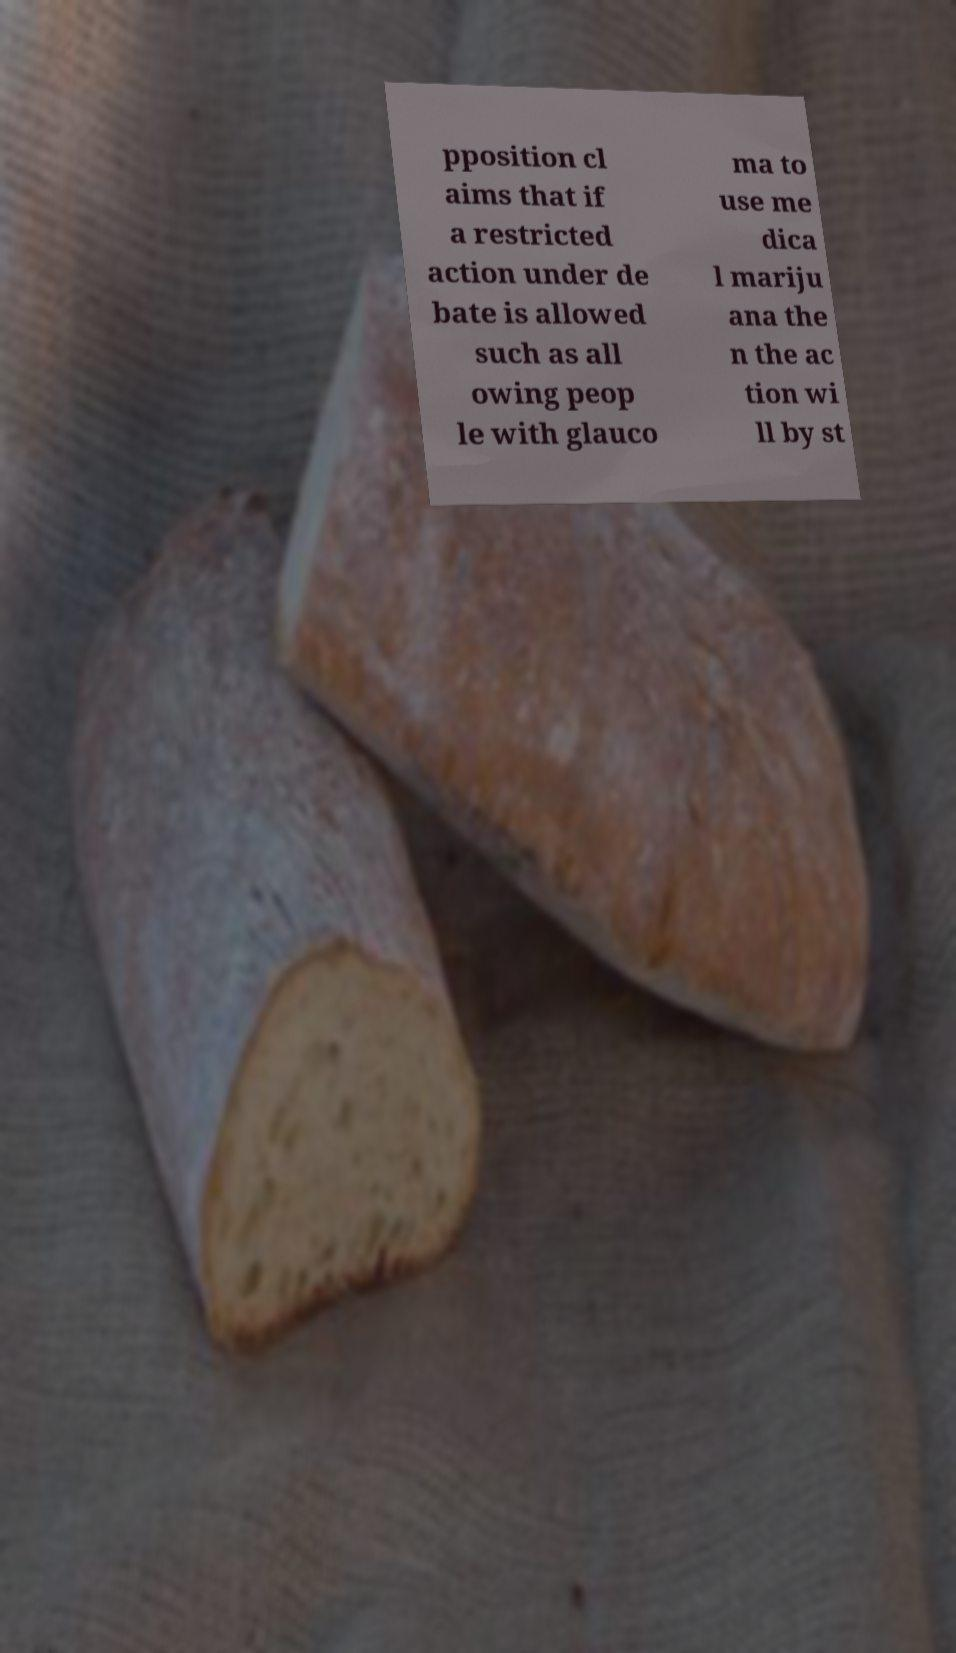Please identify and transcribe the text found in this image. pposition cl aims that if a restricted action under de bate is allowed such as all owing peop le with glauco ma to use me dica l mariju ana the n the ac tion wi ll by st 